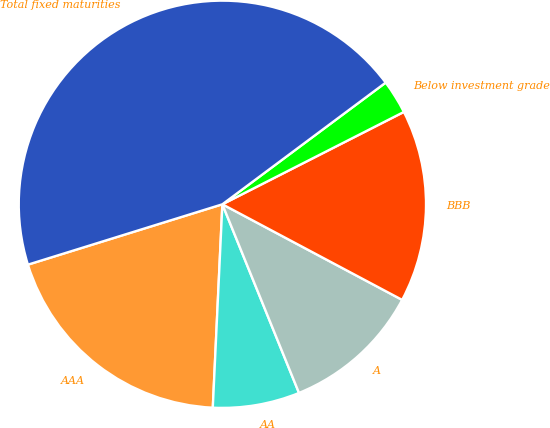Convert chart to OTSL. <chart><loc_0><loc_0><loc_500><loc_500><pie_chart><fcel>AAA<fcel>AA<fcel>A<fcel>BBB<fcel>Below investment grade<fcel>Total fixed maturities<nl><fcel>19.46%<fcel>6.89%<fcel>11.08%<fcel>15.27%<fcel>2.7%<fcel>44.6%<nl></chart> 